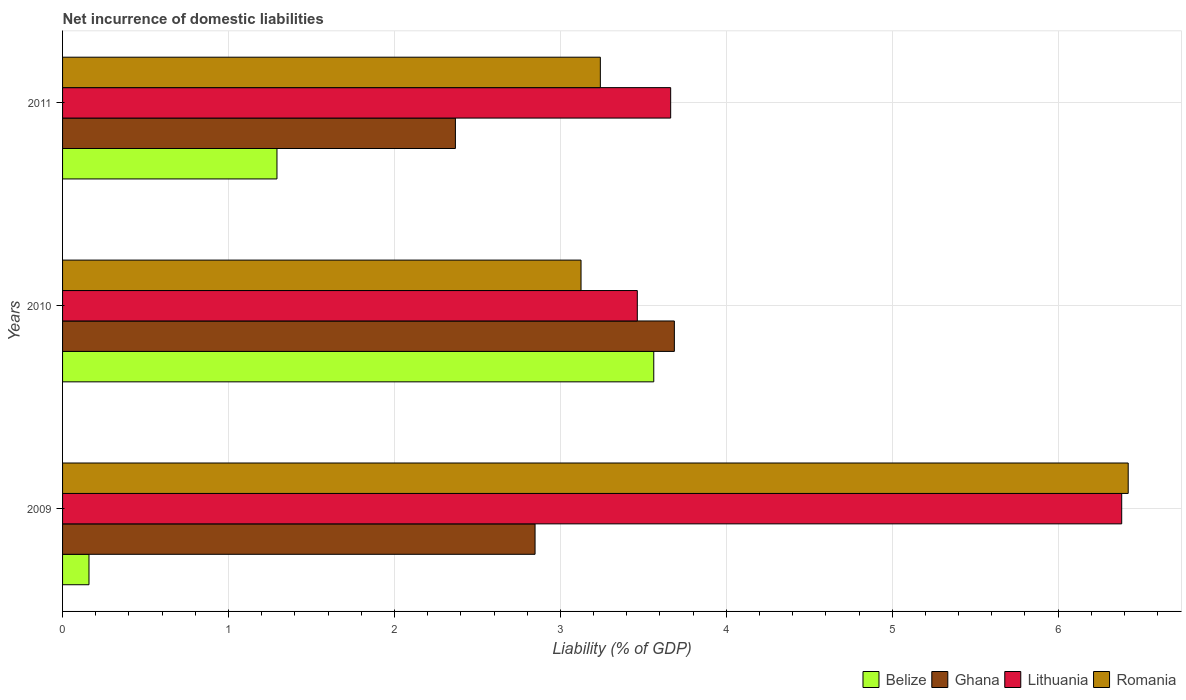How many groups of bars are there?
Your response must be concise. 3. Are the number of bars per tick equal to the number of legend labels?
Provide a succinct answer. Yes. Are the number of bars on each tick of the Y-axis equal?
Offer a very short reply. Yes. How many bars are there on the 2nd tick from the top?
Offer a terse response. 4. How many bars are there on the 2nd tick from the bottom?
Make the answer very short. 4. What is the label of the 1st group of bars from the top?
Ensure brevity in your answer.  2011. In how many cases, is the number of bars for a given year not equal to the number of legend labels?
Your answer should be compact. 0. What is the net incurrence of domestic liabilities in Ghana in 2010?
Give a very brief answer. 3.69. Across all years, what is the maximum net incurrence of domestic liabilities in Ghana?
Your response must be concise. 3.69. Across all years, what is the minimum net incurrence of domestic liabilities in Belize?
Offer a very short reply. 0.16. In which year was the net incurrence of domestic liabilities in Belize maximum?
Your answer should be very brief. 2010. In which year was the net incurrence of domestic liabilities in Lithuania minimum?
Your answer should be very brief. 2010. What is the total net incurrence of domestic liabilities in Ghana in the graph?
Provide a succinct answer. 8.9. What is the difference between the net incurrence of domestic liabilities in Ghana in 2010 and that in 2011?
Keep it short and to the point. 1.32. What is the difference between the net incurrence of domestic liabilities in Romania in 2010 and the net incurrence of domestic liabilities in Ghana in 2009?
Ensure brevity in your answer.  0.28. What is the average net incurrence of domestic liabilities in Romania per year?
Your answer should be very brief. 4.26. In the year 2010, what is the difference between the net incurrence of domestic liabilities in Ghana and net incurrence of domestic liabilities in Belize?
Give a very brief answer. 0.12. In how many years, is the net incurrence of domestic liabilities in Romania greater than 2 %?
Offer a very short reply. 3. What is the ratio of the net incurrence of domestic liabilities in Romania in 2009 to that in 2010?
Your response must be concise. 2.06. Is the net incurrence of domestic liabilities in Lithuania in 2009 less than that in 2011?
Offer a terse response. No. What is the difference between the highest and the second highest net incurrence of domestic liabilities in Lithuania?
Provide a short and direct response. 2.72. What is the difference between the highest and the lowest net incurrence of domestic liabilities in Ghana?
Make the answer very short. 1.32. Is the sum of the net incurrence of domestic liabilities in Romania in 2010 and 2011 greater than the maximum net incurrence of domestic liabilities in Belize across all years?
Your answer should be very brief. Yes. What does the 2nd bar from the top in 2009 represents?
Make the answer very short. Lithuania. What does the 1st bar from the bottom in 2010 represents?
Your response must be concise. Belize. Does the graph contain any zero values?
Your answer should be compact. No. What is the title of the graph?
Your answer should be very brief. Net incurrence of domestic liabilities. Does "Finland" appear as one of the legend labels in the graph?
Offer a terse response. No. What is the label or title of the X-axis?
Your answer should be very brief. Liability (% of GDP). What is the Liability (% of GDP) in Belize in 2009?
Give a very brief answer. 0.16. What is the Liability (% of GDP) of Ghana in 2009?
Keep it short and to the point. 2.85. What is the Liability (% of GDP) in Lithuania in 2009?
Offer a very short reply. 6.38. What is the Liability (% of GDP) of Romania in 2009?
Ensure brevity in your answer.  6.42. What is the Liability (% of GDP) in Belize in 2010?
Ensure brevity in your answer.  3.56. What is the Liability (% of GDP) of Ghana in 2010?
Ensure brevity in your answer.  3.69. What is the Liability (% of GDP) in Lithuania in 2010?
Your answer should be very brief. 3.46. What is the Liability (% of GDP) in Romania in 2010?
Offer a very short reply. 3.12. What is the Liability (% of GDP) in Belize in 2011?
Provide a short and direct response. 1.29. What is the Liability (% of GDP) in Ghana in 2011?
Provide a short and direct response. 2.37. What is the Liability (% of GDP) of Lithuania in 2011?
Provide a succinct answer. 3.66. What is the Liability (% of GDP) of Romania in 2011?
Give a very brief answer. 3.24. Across all years, what is the maximum Liability (% of GDP) of Belize?
Keep it short and to the point. 3.56. Across all years, what is the maximum Liability (% of GDP) of Ghana?
Your answer should be compact. 3.69. Across all years, what is the maximum Liability (% of GDP) in Lithuania?
Your response must be concise. 6.38. Across all years, what is the maximum Liability (% of GDP) in Romania?
Offer a very short reply. 6.42. Across all years, what is the minimum Liability (% of GDP) in Belize?
Your answer should be compact. 0.16. Across all years, what is the minimum Liability (% of GDP) in Ghana?
Offer a terse response. 2.37. Across all years, what is the minimum Liability (% of GDP) of Lithuania?
Ensure brevity in your answer.  3.46. Across all years, what is the minimum Liability (% of GDP) of Romania?
Make the answer very short. 3.12. What is the total Liability (% of GDP) in Belize in the graph?
Your answer should be very brief. 5.01. What is the total Liability (% of GDP) in Ghana in the graph?
Provide a succinct answer. 8.9. What is the total Liability (% of GDP) in Lithuania in the graph?
Your answer should be very brief. 13.51. What is the total Liability (% of GDP) of Romania in the graph?
Make the answer very short. 12.79. What is the difference between the Liability (% of GDP) of Belize in 2009 and that in 2010?
Ensure brevity in your answer.  -3.4. What is the difference between the Liability (% of GDP) of Ghana in 2009 and that in 2010?
Your answer should be very brief. -0.84. What is the difference between the Liability (% of GDP) of Lithuania in 2009 and that in 2010?
Offer a very short reply. 2.92. What is the difference between the Liability (% of GDP) of Romania in 2009 and that in 2010?
Your answer should be very brief. 3.3. What is the difference between the Liability (% of GDP) of Belize in 2009 and that in 2011?
Your response must be concise. -1.13. What is the difference between the Liability (% of GDP) in Ghana in 2009 and that in 2011?
Provide a short and direct response. 0.48. What is the difference between the Liability (% of GDP) in Lithuania in 2009 and that in 2011?
Keep it short and to the point. 2.72. What is the difference between the Liability (% of GDP) of Romania in 2009 and that in 2011?
Offer a terse response. 3.18. What is the difference between the Liability (% of GDP) in Belize in 2010 and that in 2011?
Provide a succinct answer. 2.27. What is the difference between the Liability (% of GDP) in Ghana in 2010 and that in 2011?
Make the answer very short. 1.32. What is the difference between the Liability (% of GDP) in Lithuania in 2010 and that in 2011?
Offer a terse response. -0.2. What is the difference between the Liability (% of GDP) of Romania in 2010 and that in 2011?
Provide a short and direct response. -0.12. What is the difference between the Liability (% of GDP) in Belize in 2009 and the Liability (% of GDP) in Ghana in 2010?
Provide a short and direct response. -3.53. What is the difference between the Liability (% of GDP) in Belize in 2009 and the Liability (% of GDP) in Lithuania in 2010?
Provide a succinct answer. -3.3. What is the difference between the Liability (% of GDP) in Belize in 2009 and the Liability (% of GDP) in Romania in 2010?
Your answer should be compact. -2.97. What is the difference between the Liability (% of GDP) of Ghana in 2009 and the Liability (% of GDP) of Lithuania in 2010?
Provide a succinct answer. -0.62. What is the difference between the Liability (% of GDP) in Ghana in 2009 and the Liability (% of GDP) in Romania in 2010?
Offer a very short reply. -0.28. What is the difference between the Liability (% of GDP) of Lithuania in 2009 and the Liability (% of GDP) of Romania in 2010?
Keep it short and to the point. 3.26. What is the difference between the Liability (% of GDP) of Belize in 2009 and the Liability (% of GDP) of Ghana in 2011?
Keep it short and to the point. -2.21. What is the difference between the Liability (% of GDP) of Belize in 2009 and the Liability (% of GDP) of Lithuania in 2011?
Your answer should be very brief. -3.51. What is the difference between the Liability (% of GDP) in Belize in 2009 and the Liability (% of GDP) in Romania in 2011?
Give a very brief answer. -3.08. What is the difference between the Liability (% of GDP) in Ghana in 2009 and the Liability (% of GDP) in Lithuania in 2011?
Ensure brevity in your answer.  -0.82. What is the difference between the Liability (% of GDP) in Ghana in 2009 and the Liability (% of GDP) in Romania in 2011?
Offer a very short reply. -0.39. What is the difference between the Liability (% of GDP) in Lithuania in 2009 and the Liability (% of GDP) in Romania in 2011?
Your answer should be compact. 3.14. What is the difference between the Liability (% of GDP) in Belize in 2010 and the Liability (% of GDP) in Ghana in 2011?
Ensure brevity in your answer.  1.2. What is the difference between the Liability (% of GDP) of Belize in 2010 and the Liability (% of GDP) of Lithuania in 2011?
Offer a terse response. -0.1. What is the difference between the Liability (% of GDP) of Belize in 2010 and the Liability (% of GDP) of Romania in 2011?
Provide a succinct answer. 0.32. What is the difference between the Liability (% of GDP) of Ghana in 2010 and the Liability (% of GDP) of Lithuania in 2011?
Provide a short and direct response. 0.02. What is the difference between the Liability (% of GDP) of Ghana in 2010 and the Liability (% of GDP) of Romania in 2011?
Provide a short and direct response. 0.45. What is the difference between the Liability (% of GDP) in Lithuania in 2010 and the Liability (% of GDP) in Romania in 2011?
Ensure brevity in your answer.  0.22. What is the average Liability (% of GDP) in Belize per year?
Your answer should be compact. 1.67. What is the average Liability (% of GDP) of Ghana per year?
Provide a short and direct response. 2.97. What is the average Liability (% of GDP) in Lithuania per year?
Your answer should be very brief. 4.5. What is the average Liability (% of GDP) of Romania per year?
Provide a short and direct response. 4.26. In the year 2009, what is the difference between the Liability (% of GDP) in Belize and Liability (% of GDP) in Ghana?
Your response must be concise. -2.69. In the year 2009, what is the difference between the Liability (% of GDP) of Belize and Liability (% of GDP) of Lithuania?
Offer a very short reply. -6.22. In the year 2009, what is the difference between the Liability (% of GDP) in Belize and Liability (% of GDP) in Romania?
Provide a succinct answer. -6.26. In the year 2009, what is the difference between the Liability (% of GDP) in Ghana and Liability (% of GDP) in Lithuania?
Offer a very short reply. -3.54. In the year 2009, what is the difference between the Liability (% of GDP) of Ghana and Liability (% of GDP) of Romania?
Give a very brief answer. -3.57. In the year 2009, what is the difference between the Liability (% of GDP) in Lithuania and Liability (% of GDP) in Romania?
Make the answer very short. -0.04. In the year 2010, what is the difference between the Liability (% of GDP) of Belize and Liability (% of GDP) of Ghana?
Your answer should be very brief. -0.12. In the year 2010, what is the difference between the Liability (% of GDP) in Belize and Liability (% of GDP) in Lithuania?
Your answer should be compact. 0.1. In the year 2010, what is the difference between the Liability (% of GDP) in Belize and Liability (% of GDP) in Romania?
Offer a terse response. 0.44. In the year 2010, what is the difference between the Liability (% of GDP) in Ghana and Liability (% of GDP) in Lithuania?
Provide a short and direct response. 0.22. In the year 2010, what is the difference between the Liability (% of GDP) of Ghana and Liability (% of GDP) of Romania?
Keep it short and to the point. 0.56. In the year 2010, what is the difference between the Liability (% of GDP) of Lithuania and Liability (% of GDP) of Romania?
Your response must be concise. 0.34. In the year 2011, what is the difference between the Liability (% of GDP) of Belize and Liability (% of GDP) of Ghana?
Make the answer very short. -1.08. In the year 2011, what is the difference between the Liability (% of GDP) in Belize and Liability (% of GDP) in Lithuania?
Give a very brief answer. -2.37. In the year 2011, what is the difference between the Liability (% of GDP) in Belize and Liability (% of GDP) in Romania?
Offer a very short reply. -1.95. In the year 2011, what is the difference between the Liability (% of GDP) in Ghana and Liability (% of GDP) in Lithuania?
Provide a succinct answer. -1.3. In the year 2011, what is the difference between the Liability (% of GDP) in Ghana and Liability (% of GDP) in Romania?
Give a very brief answer. -0.87. In the year 2011, what is the difference between the Liability (% of GDP) in Lithuania and Liability (% of GDP) in Romania?
Your answer should be compact. 0.42. What is the ratio of the Liability (% of GDP) of Belize in 2009 to that in 2010?
Make the answer very short. 0.04. What is the ratio of the Liability (% of GDP) in Ghana in 2009 to that in 2010?
Your answer should be compact. 0.77. What is the ratio of the Liability (% of GDP) in Lithuania in 2009 to that in 2010?
Provide a succinct answer. 1.84. What is the ratio of the Liability (% of GDP) of Romania in 2009 to that in 2010?
Offer a terse response. 2.06. What is the ratio of the Liability (% of GDP) of Belize in 2009 to that in 2011?
Provide a short and direct response. 0.12. What is the ratio of the Liability (% of GDP) of Ghana in 2009 to that in 2011?
Keep it short and to the point. 1.2. What is the ratio of the Liability (% of GDP) in Lithuania in 2009 to that in 2011?
Give a very brief answer. 1.74. What is the ratio of the Liability (% of GDP) in Romania in 2009 to that in 2011?
Give a very brief answer. 1.98. What is the ratio of the Liability (% of GDP) of Belize in 2010 to that in 2011?
Give a very brief answer. 2.76. What is the ratio of the Liability (% of GDP) in Ghana in 2010 to that in 2011?
Your answer should be very brief. 1.56. What is the ratio of the Liability (% of GDP) of Lithuania in 2010 to that in 2011?
Offer a terse response. 0.95. What is the ratio of the Liability (% of GDP) in Romania in 2010 to that in 2011?
Provide a succinct answer. 0.96. What is the difference between the highest and the second highest Liability (% of GDP) in Belize?
Provide a succinct answer. 2.27. What is the difference between the highest and the second highest Liability (% of GDP) in Ghana?
Make the answer very short. 0.84. What is the difference between the highest and the second highest Liability (% of GDP) of Lithuania?
Give a very brief answer. 2.72. What is the difference between the highest and the second highest Liability (% of GDP) in Romania?
Your response must be concise. 3.18. What is the difference between the highest and the lowest Liability (% of GDP) of Belize?
Your response must be concise. 3.4. What is the difference between the highest and the lowest Liability (% of GDP) of Ghana?
Your answer should be very brief. 1.32. What is the difference between the highest and the lowest Liability (% of GDP) of Lithuania?
Offer a very short reply. 2.92. What is the difference between the highest and the lowest Liability (% of GDP) of Romania?
Your response must be concise. 3.3. 